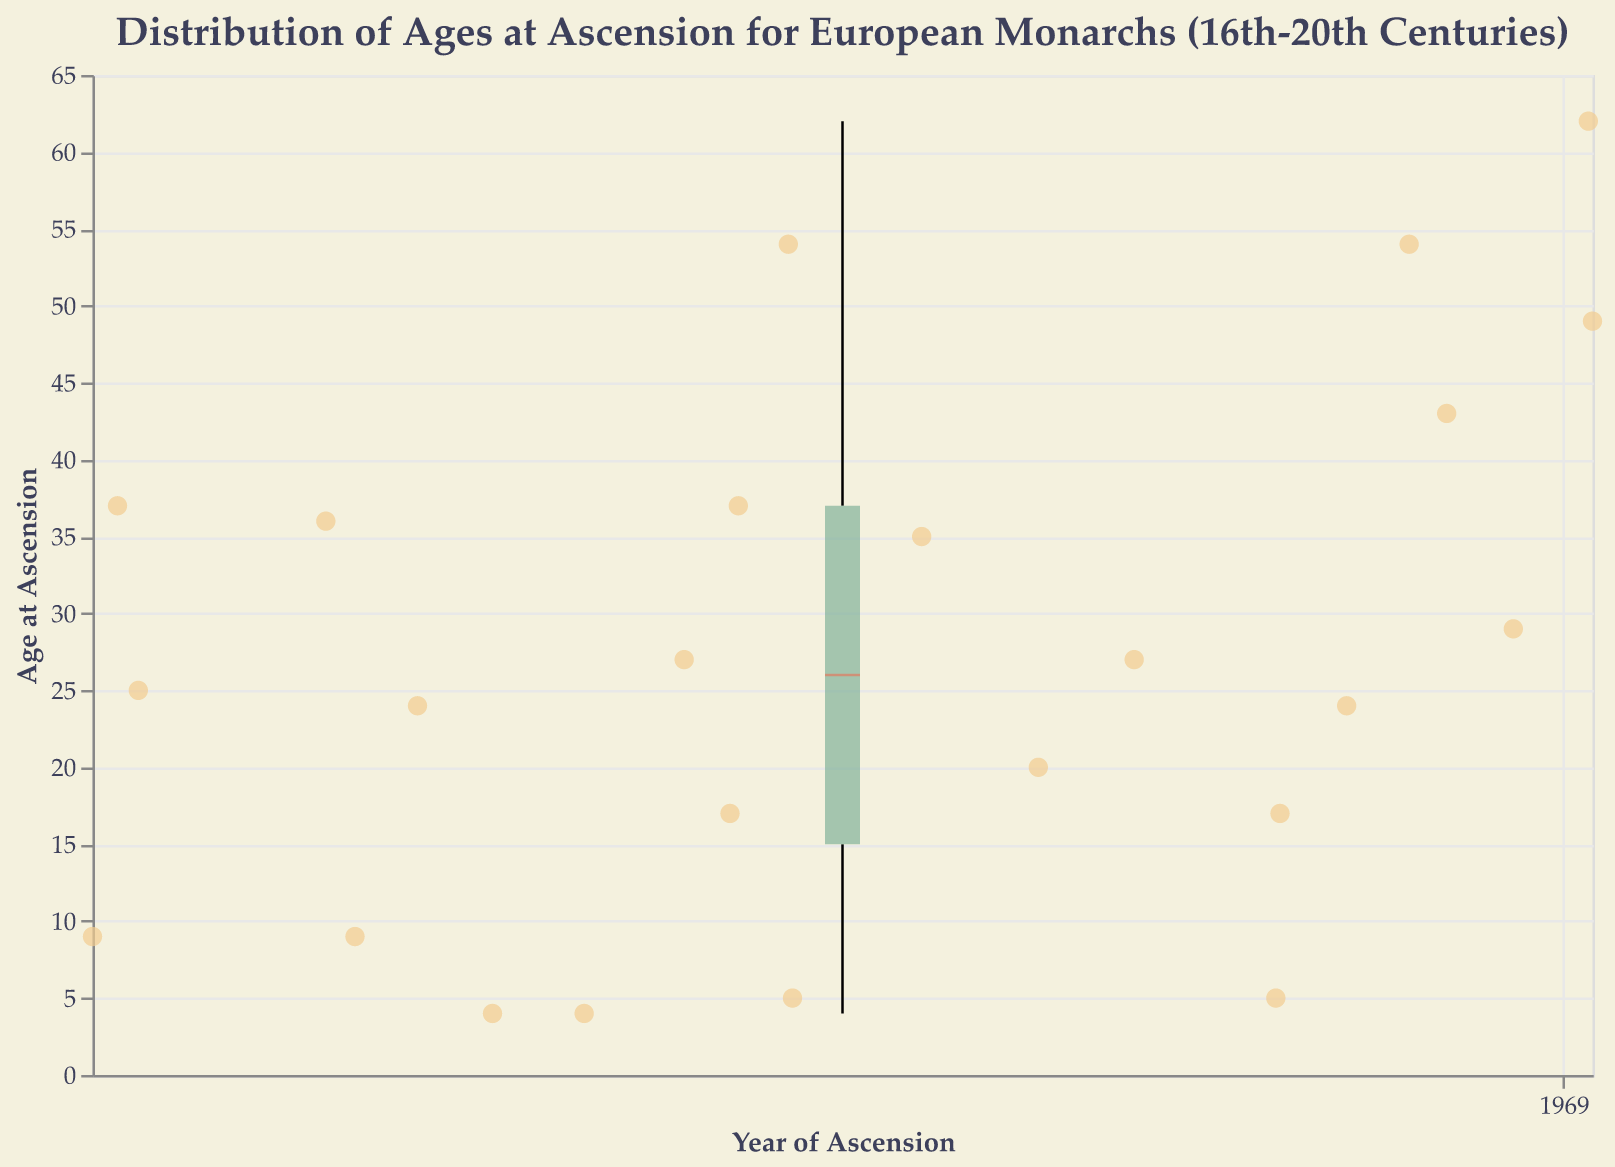What is the title of the plot? The title of a plot is typically located at the top and it provides a summary of what the plot represents. In this case, the title should summarize the distribution of ages at ascension for European monarchs across several centuries.
Answer: Distribution of Ages at Ascension for European Monarchs (16th-20th Centuries) How many monarchs ascended the throne at the age of 4? To answer this, count the scatter points that correspond to the age of 4 in the figure. These points will be marked around the y-axis value of 4.
Answer: 3 What is the median age at ascension according to the plot? The median age at ascension can be found as a distinct line within the box of the box plot. It typically represents the middle value of the dataset.
Answer: Around 27 Which country’s monarch ascended the throne at the youngest age, and how old were they? Identify the scatter point that represents the youngest age at ascension by looking at the lowest point on the y-axis with its tooltip information.
Answer: France, 4 Are there more monarchs who ascended the throne in the 16th century or in the 19th century? Identify the scatter points in the specified centuries (16th: 1500-1599, 19th: 1800-1899). Count the points in each range and compare the totals.
Answer: 16th century: 4, 19th century: 4 Which monarch ascended to the throne at the oldest age, and what was their age? Look for the highest scatter point on the y-axis and check its tooltip for the monarch's name and age.
Answer: Frederick VIII of Denmark, 62 Compare the median ages at ascension for monarchs from England and France. Which country’s median age is higher? Identify the respective box plots and their median lines for England and France. Compare which median line (horizontal line within the box) is higher on the y-axis.
Answer: England What's the range of ages at ascension for monarchs from Spain? The range can be determined from the lowest and highest points of the whiskers in the box plot for Spain. This marks the minimum and maximum ages in the dataset for Spanish monarchs.
Answer: 4 to 35 What does the width of the box in the boxplot represent? The width of the box in a box plot indicates the interquartile range (IQR), which is the range between the first quartile (Q1) and the third quartile (Q3), representing the middle 50% of the data.
Answer: Interquartile Range (IQR) Did any monarch ascend the throne more than once, according to the figure? Look for any scatter points that are at the same y-axis value (age) and from the same country but with different x-axis values (years). If no such pattern exists, then no monarch ascended more than once in this dataset.
Answer: No 